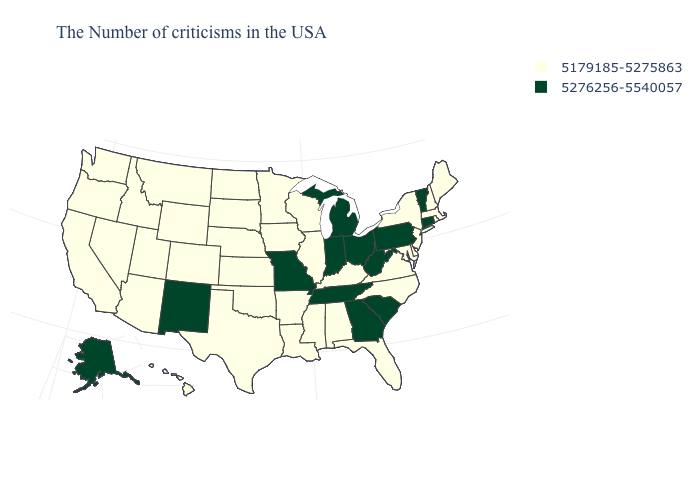Name the states that have a value in the range 5179185-5275863?
Short answer required. Maine, Massachusetts, Rhode Island, New Hampshire, New York, New Jersey, Delaware, Maryland, Virginia, North Carolina, Florida, Kentucky, Alabama, Wisconsin, Illinois, Mississippi, Louisiana, Arkansas, Minnesota, Iowa, Kansas, Nebraska, Oklahoma, Texas, South Dakota, North Dakota, Wyoming, Colorado, Utah, Montana, Arizona, Idaho, Nevada, California, Washington, Oregon, Hawaii. Name the states that have a value in the range 5179185-5275863?
Answer briefly. Maine, Massachusetts, Rhode Island, New Hampshire, New York, New Jersey, Delaware, Maryland, Virginia, North Carolina, Florida, Kentucky, Alabama, Wisconsin, Illinois, Mississippi, Louisiana, Arkansas, Minnesota, Iowa, Kansas, Nebraska, Oklahoma, Texas, South Dakota, North Dakota, Wyoming, Colorado, Utah, Montana, Arizona, Idaho, Nevada, California, Washington, Oregon, Hawaii. Does Iowa have the lowest value in the MidWest?
Be succinct. Yes. Name the states that have a value in the range 5276256-5540057?
Be succinct. Vermont, Connecticut, Pennsylvania, South Carolina, West Virginia, Ohio, Georgia, Michigan, Indiana, Tennessee, Missouri, New Mexico, Alaska. Name the states that have a value in the range 5276256-5540057?
Keep it brief. Vermont, Connecticut, Pennsylvania, South Carolina, West Virginia, Ohio, Georgia, Michigan, Indiana, Tennessee, Missouri, New Mexico, Alaska. What is the lowest value in states that border Washington?
Write a very short answer. 5179185-5275863. What is the highest value in the West ?
Short answer required. 5276256-5540057. What is the highest value in the West ?
Short answer required. 5276256-5540057. What is the lowest value in the MidWest?
Concise answer only. 5179185-5275863. Among the states that border Michigan , does Indiana have the highest value?
Short answer required. Yes. What is the highest value in states that border Washington?
Give a very brief answer. 5179185-5275863. Among the states that border Pennsylvania , does New Jersey have the highest value?
Be succinct. No. What is the lowest value in the USA?
Give a very brief answer. 5179185-5275863. Does Vermont have the lowest value in the Northeast?
Give a very brief answer. No. Is the legend a continuous bar?
Concise answer only. No. 